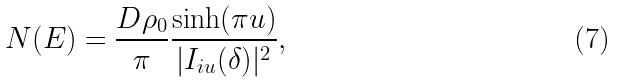<formula> <loc_0><loc_0><loc_500><loc_500>N ( E ) = \frac { D \rho _ { 0 } } { \pi } \frac { \sinh ( \pi u ) } { | I _ { i u } ( \delta ) | ^ { 2 } } ,</formula> 